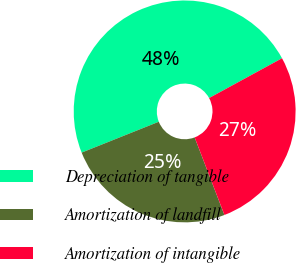Convert chart to OTSL. <chart><loc_0><loc_0><loc_500><loc_500><pie_chart><fcel>Depreciation of tangible<fcel>Amortization of landfill<fcel>Amortization of intangible<nl><fcel>48.1%<fcel>24.78%<fcel>27.11%<nl></chart> 